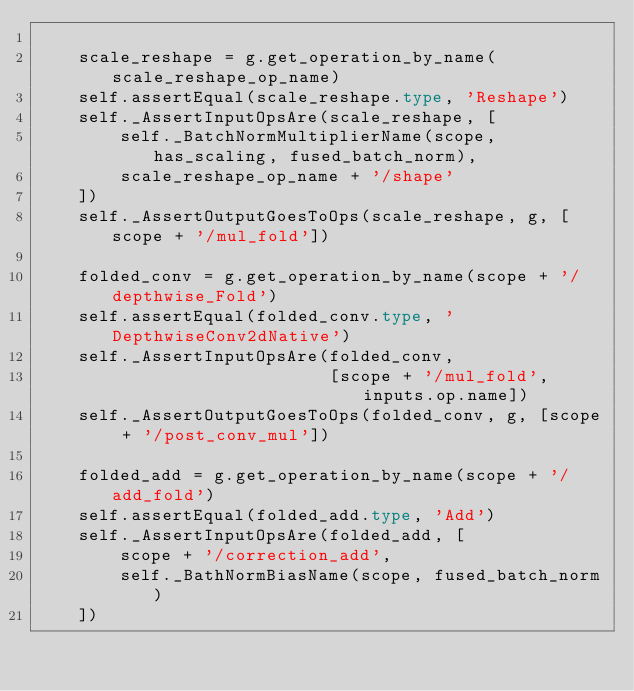<code> <loc_0><loc_0><loc_500><loc_500><_Python_>
    scale_reshape = g.get_operation_by_name(scale_reshape_op_name)
    self.assertEqual(scale_reshape.type, 'Reshape')
    self._AssertInputOpsAre(scale_reshape, [
        self._BatchNormMultiplierName(scope, has_scaling, fused_batch_norm),
        scale_reshape_op_name + '/shape'
    ])
    self._AssertOutputGoesToOps(scale_reshape, g, [scope + '/mul_fold'])

    folded_conv = g.get_operation_by_name(scope + '/depthwise_Fold')
    self.assertEqual(folded_conv.type, 'DepthwiseConv2dNative')
    self._AssertInputOpsAre(folded_conv,
                            [scope + '/mul_fold', inputs.op.name])
    self._AssertOutputGoesToOps(folded_conv, g, [scope + '/post_conv_mul'])

    folded_add = g.get_operation_by_name(scope + '/add_fold')
    self.assertEqual(folded_add.type, 'Add')
    self._AssertInputOpsAre(folded_add, [
        scope + '/correction_add',
        self._BathNormBiasName(scope, fused_batch_norm)
    ])</code> 